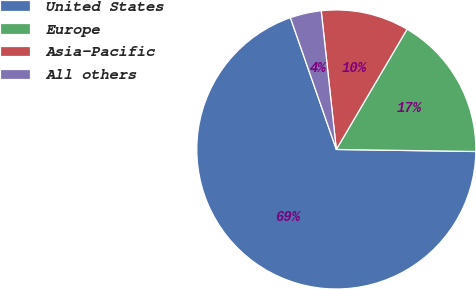Convert chart to OTSL. <chart><loc_0><loc_0><loc_500><loc_500><pie_chart><fcel>United States<fcel>Europe<fcel>Asia-Pacific<fcel>All others<nl><fcel>69.43%<fcel>16.77%<fcel>10.19%<fcel>3.61%<nl></chart> 